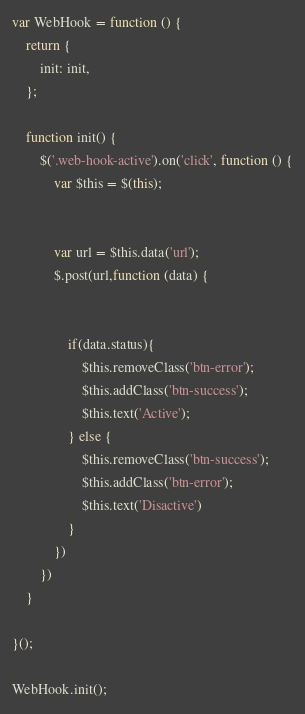<code> <loc_0><loc_0><loc_500><loc_500><_JavaScript_>var WebHook = function () {
    return {
        init: init,
    };

    function init() {
        $('.web-hook-active').on('click', function () {
            var $this = $(this);


            var url = $this.data('url');
            $.post(url,function (data) {


                if(data.status){
                    $this.removeClass('btn-error');
                    $this.addClass('btn-success');
                    $this.text('Active');
                } else {
                    $this.removeClass('btn-success');
                    $this.addClass('btn-error');
                    $this.text('Disactive')
                }
            })
        })
    }

}();

WebHook.init();</code> 